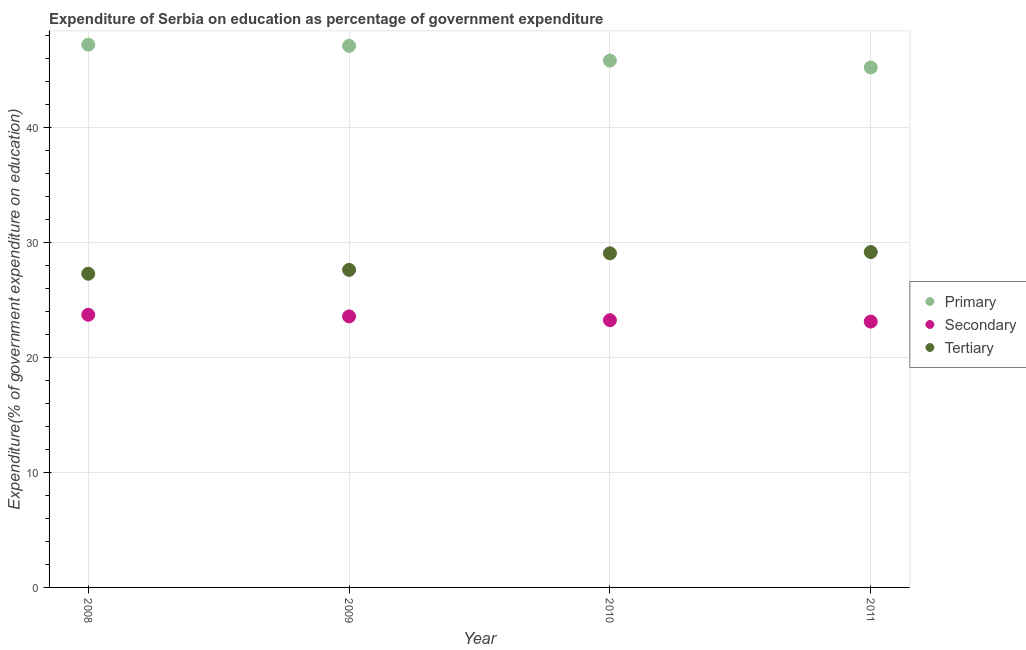Is the number of dotlines equal to the number of legend labels?
Provide a succinct answer. Yes. What is the expenditure on secondary education in 2009?
Your answer should be very brief. 23.59. Across all years, what is the maximum expenditure on tertiary education?
Make the answer very short. 29.19. Across all years, what is the minimum expenditure on primary education?
Your response must be concise. 45.26. In which year was the expenditure on tertiary education minimum?
Offer a terse response. 2008. What is the total expenditure on tertiary education in the graph?
Your response must be concise. 113.21. What is the difference between the expenditure on secondary education in 2008 and that in 2010?
Provide a succinct answer. 0.47. What is the difference between the expenditure on primary education in 2011 and the expenditure on tertiary education in 2009?
Ensure brevity in your answer.  17.62. What is the average expenditure on tertiary education per year?
Keep it short and to the point. 28.3. In the year 2009, what is the difference between the expenditure on tertiary education and expenditure on secondary education?
Your answer should be compact. 4.05. In how many years, is the expenditure on secondary education greater than 46 %?
Ensure brevity in your answer.  0. What is the ratio of the expenditure on tertiary education in 2009 to that in 2010?
Your response must be concise. 0.95. Is the expenditure on secondary education in 2008 less than that in 2010?
Make the answer very short. No. Is the difference between the expenditure on primary education in 2009 and 2010 greater than the difference between the expenditure on secondary education in 2009 and 2010?
Provide a succinct answer. Yes. What is the difference between the highest and the second highest expenditure on secondary education?
Provide a succinct answer. 0.14. What is the difference between the highest and the lowest expenditure on tertiary education?
Make the answer very short. 1.89. Does the expenditure on primary education monotonically increase over the years?
Provide a short and direct response. No. Is the expenditure on tertiary education strictly greater than the expenditure on secondary education over the years?
Your answer should be very brief. Yes. How many dotlines are there?
Offer a very short reply. 3. How many years are there in the graph?
Your response must be concise. 4. What is the difference between two consecutive major ticks on the Y-axis?
Your response must be concise. 10. Are the values on the major ticks of Y-axis written in scientific E-notation?
Ensure brevity in your answer.  No. Does the graph contain grids?
Offer a very short reply. Yes. Where does the legend appear in the graph?
Offer a very short reply. Center right. How are the legend labels stacked?
Provide a short and direct response. Vertical. What is the title of the graph?
Provide a short and direct response. Expenditure of Serbia on education as percentage of government expenditure. Does "Infant(female)" appear as one of the legend labels in the graph?
Your answer should be compact. No. What is the label or title of the X-axis?
Your response must be concise. Year. What is the label or title of the Y-axis?
Offer a very short reply. Expenditure(% of government expenditure on education). What is the Expenditure(% of government expenditure on education) in Primary in 2008?
Offer a terse response. 47.24. What is the Expenditure(% of government expenditure on education) of Secondary in 2008?
Offer a terse response. 23.73. What is the Expenditure(% of government expenditure on education) in Tertiary in 2008?
Give a very brief answer. 27.3. What is the Expenditure(% of government expenditure on education) of Primary in 2009?
Ensure brevity in your answer.  47.14. What is the Expenditure(% of government expenditure on education) of Secondary in 2009?
Provide a succinct answer. 23.59. What is the Expenditure(% of government expenditure on education) of Tertiary in 2009?
Provide a succinct answer. 27.64. What is the Expenditure(% of government expenditure on education) in Primary in 2010?
Ensure brevity in your answer.  45.86. What is the Expenditure(% of government expenditure on education) of Secondary in 2010?
Give a very brief answer. 23.26. What is the Expenditure(% of government expenditure on education) of Tertiary in 2010?
Ensure brevity in your answer.  29.08. What is the Expenditure(% of government expenditure on education) of Primary in 2011?
Your answer should be compact. 45.26. What is the Expenditure(% of government expenditure on education) in Secondary in 2011?
Provide a succinct answer. 23.14. What is the Expenditure(% of government expenditure on education) in Tertiary in 2011?
Your answer should be compact. 29.19. Across all years, what is the maximum Expenditure(% of government expenditure on education) in Primary?
Your answer should be compact. 47.24. Across all years, what is the maximum Expenditure(% of government expenditure on education) in Secondary?
Ensure brevity in your answer.  23.73. Across all years, what is the maximum Expenditure(% of government expenditure on education) in Tertiary?
Keep it short and to the point. 29.19. Across all years, what is the minimum Expenditure(% of government expenditure on education) of Primary?
Give a very brief answer. 45.26. Across all years, what is the minimum Expenditure(% of government expenditure on education) of Secondary?
Your answer should be compact. 23.14. Across all years, what is the minimum Expenditure(% of government expenditure on education) of Tertiary?
Keep it short and to the point. 27.3. What is the total Expenditure(% of government expenditure on education) in Primary in the graph?
Provide a succinct answer. 185.49. What is the total Expenditure(% of government expenditure on education) in Secondary in the graph?
Your answer should be very brief. 93.72. What is the total Expenditure(% of government expenditure on education) of Tertiary in the graph?
Provide a succinct answer. 113.21. What is the difference between the Expenditure(% of government expenditure on education) in Primary in 2008 and that in 2009?
Your response must be concise. 0.1. What is the difference between the Expenditure(% of government expenditure on education) of Secondary in 2008 and that in 2009?
Offer a terse response. 0.14. What is the difference between the Expenditure(% of government expenditure on education) of Tertiary in 2008 and that in 2009?
Keep it short and to the point. -0.34. What is the difference between the Expenditure(% of government expenditure on education) of Primary in 2008 and that in 2010?
Your response must be concise. 1.38. What is the difference between the Expenditure(% of government expenditure on education) of Secondary in 2008 and that in 2010?
Offer a terse response. 0.47. What is the difference between the Expenditure(% of government expenditure on education) of Tertiary in 2008 and that in 2010?
Your response must be concise. -1.78. What is the difference between the Expenditure(% of government expenditure on education) in Primary in 2008 and that in 2011?
Keep it short and to the point. 1.98. What is the difference between the Expenditure(% of government expenditure on education) of Secondary in 2008 and that in 2011?
Ensure brevity in your answer.  0.59. What is the difference between the Expenditure(% of government expenditure on education) of Tertiary in 2008 and that in 2011?
Your answer should be compact. -1.89. What is the difference between the Expenditure(% of government expenditure on education) of Primary in 2009 and that in 2010?
Provide a succinct answer. 1.28. What is the difference between the Expenditure(% of government expenditure on education) of Secondary in 2009 and that in 2010?
Your answer should be compact. 0.33. What is the difference between the Expenditure(% of government expenditure on education) in Tertiary in 2009 and that in 2010?
Ensure brevity in your answer.  -1.44. What is the difference between the Expenditure(% of government expenditure on education) in Primary in 2009 and that in 2011?
Offer a very short reply. 1.88. What is the difference between the Expenditure(% of government expenditure on education) in Secondary in 2009 and that in 2011?
Provide a short and direct response. 0.45. What is the difference between the Expenditure(% of government expenditure on education) in Tertiary in 2009 and that in 2011?
Make the answer very short. -1.55. What is the difference between the Expenditure(% of government expenditure on education) in Primary in 2010 and that in 2011?
Offer a terse response. 0.6. What is the difference between the Expenditure(% of government expenditure on education) of Secondary in 2010 and that in 2011?
Offer a very short reply. 0.12. What is the difference between the Expenditure(% of government expenditure on education) in Tertiary in 2010 and that in 2011?
Offer a very short reply. -0.11. What is the difference between the Expenditure(% of government expenditure on education) of Primary in 2008 and the Expenditure(% of government expenditure on education) of Secondary in 2009?
Give a very brief answer. 23.65. What is the difference between the Expenditure(% of government expenditure on education) in Primary in 2008 and the Expenditure(% of government expenditure on education) in Tertiary in 2009?
Keep it short and to the point. 19.6. What is the difference between the Expenditure(% of government expenditure on education) in Secondary in 2008 and the Expenditure(% of government expenditure on education) in Tertiary in 2009?
Ensure brevity in your answer.  -3.91. What is the difference between the Expenditure(% of government expenditure on education) of Primary in 2008 and the Expenditure(% of government expenditure on education) of Secondary in 2010?
Offer a terse response. 23.98. What is the difference between the Expenditure(% of government expenditure on education) of Primary in 2008 and the Expenditure(% of government expenditure on education) of Tertiary in 2010?
Your answer should be very brief. 18.16. What is the difference between the Expenditure(% of government expenditure on education) in Secondary in 2008 and the Expenditure(% of government expenditure on education) in Tertiary in 2010?
Ensure brevity in your answer.  -5.35. What is the difference between the Expenditure(% of government expenditure on education) in Primary in 2008 and the Expenditure(% of government expenditure on education) in Secondary in 2011?
Make the answer very short. 24.1. What is the difference between the Expenditure(% of government expenditure on education) in Primary in 2008 and the Expenditure(% of government expenditure on education) in Tertiary in 2011?
Your answer should be very brief. 18.05. What is the difference between the Expenditure(% of government expenditure on education) in Secondary in 2008 and the Expenditure(% of government expenditure on education) in Tertiary in 2011?
Provide a short and direct response. -5.46. What is the difference between the Expenditure(% of government expenditure on education) in Primary in 2009 and the Expenditure(% of government expenditure on education) in Secondary in 2010?
Keep it short and to the point. 23.88. What is the difference between the Expenditure(% of government expenditure on education) in Primary in 2009 and the Expenditure(% of government expenditure on education) in Tertiary in 2010?
Your response must be concise. 18.05. What is the difference between the Expenditure(% of government expenditure on education) of Secondary in 2009 and the Expenditure(% of government expenditure on education) of Tertiary in 2010?
Make the answer very short. -5.49. What is the difference between the Expenditure(% of government expenditure on education) in Primary in 2009 and the Expenditure(% of government expenditure on education) in Secondary in 2011?
Provide a succinct answer. 24. What is the difference between the Expenditure(% of government expenditure on education) in Primary in 2009 and the Expenditure(% of government expenditure on education) in Tertiary in 2011?
Give a very brief answer. 17.95. What is the difference between the Expenditure(% of government expenditure on education) of Secondary in 2009 and the Expenditure(% of government expenditure on education) of Tertiary in 2011?
Keep it short and to the point. -5.6. What is the difference between the Expenditure(% of government expenditure on education) in Primary in 2010 and the Expenditure(% of government expenditure on education) in Secondary in 2011?
Ensure brevity in your answer.  22.72. What is the difference between the Expenditure(% of government expenditure on education) in Primary in 2010 and the Expenditure(% of government expenditure on education) in Tertiary in 2011?
Ensure brevity in your answer.  16.66. What is the difference between the Expenditure(% of government expenditure on education) in Secondary in 2010 and the Expenditure(% of government expenditure on education) in Tertiary in 2011?
Offer a very short reply. -5.93. What is the average Expenditure(% of government expenditure on education) of Primary per year?
Offer a very short reply. 46.37. What is the average Expenditure(% of government expenditure on education) of Secondary per year?
Your response must be concise. 23.43. What is the average Expenditure(% of government expenditure on education) in Tertiary per year?
Provide a short and direct response. 28.3. In the year 2008, what is the difference between the Expenditure(% of government expenditure on education) in Primary and Expenditure(% of government expenditure on education) in Secondary?
Your answer should be compact. 23.51. In the year 2008, what is the difference between the Expenditure(% of government expenditure on education) in Primary and Expenditure(% of government expenditure on education) in Tertiary?
Provide a short and direct response. 19.94. In the year 2008, what is the difference between the Expenditure(% of government expenditure on education) in Secondary and Expenditure(% of government expenditure on education) in Tertiary?
Your response must be concise. -3.57. In the year 2009, what is the difference between the Expenditure(% of government expenditure on education) of Primary and Expenditure(% of government expenditure on education) of Secondary?
Keep it short and to the point. 23.55. In the year 2009, what is the difference between the Expenditure(% of government expenditure on education) of Primary and Expenditure(% of government expenditure on education) of Tertiary?
Make the answer very short. 19.5. In the year 2009, what is the difference between the Expenditure(% of government expenditure on education) of Secondary and Expenditure(% of government expenditure on education) of Tertiary?
Offer a terse response. -4.05. In the year 2010, what is the difference between the Expenditure(% of government expenditure on education) of Primary and Expenditure(% of government expenditure on education) of Secondary?
Ensure brevity in your answer.  22.6. In the year 2010, what is the difference between the Expenditure(% of government expenditure on education) in Primary and Expenditure(% of government expenditure on education) in Tertiary?
Ensure brevity in your answer.  16.77. In the year 2010, what is the difference between the Expenditure(% of government expenditure on education) of Secondary and Expenditure(% of government expenditure on education) of Tertiary?
Keep it short and to the point. -5.82. In the year 2011, what is the difference between the Expenditure(% of government expenditure on education) in Primary and Expenditure(% of government expenditure on education) in Secondary?
Your answer should be very brief. 22.12. In the year 2011, what is the difference between the Expenditure(% of government expenditure on education) of Primary and Expenditure(% of government expenditure on education) of Tertiary?
Your answer should be very brief. 16.07. In the year 2011, what is the difference between the Expenditure(% of government expenditure on education) in Secondary and Expenditure(% of government expenditure on education) in Tertiary?
Provide a succinct answer. -6.05. What is the ratio of the Expenditure(% of government expenditure on education) in Primary in 2008 to that in 2009?
Make the answer very short. 1. What is the ratio of the Expenditure(% of government expenditure on education) of Primary in 2008 to that in 2010?
Give a very brief answer. 1.03. What is the ratio of the Expenditure(% of government expenditure on education) of Secondary in 2008 to that in 2010?
Provide a short and direct response. 1.02. What is the ratio of the Expenditure(% of government expenditure on education) of Tertiary in 2008 to that in 2010?
Your answer should be compact. 0.94. What is the ratio of the Expenditure(% of government expenditure on education) of Primary in 2008 to that in 2011?
Ensure brevity in your answer.  1.04. What is the ratio of the Expenditure(% of government expenditure on education) in Secondary in 2008 to that in 2011?
Ensure brevity in your answer.  1.03. What is the ratio of the Expenditure(% of government expenditure on education) in Tertiary in 2008 to that in 2011?
Give a very brief answer. 0.94. What is the ratio of the Expenditure(% of government expenditure on education) in Primary in 2009 to that in 2010?
Your response must be concise. 1.03. What is the ratio of the Expenditure(% of government expenditure on education) of Secondary in 2009 to that in 2010?
Keep it short and to the point. 1.01. What is the ratio of the Expenditure(% of government expenditure on education) of Tertiary in 2009 to that in 2010?
Your answer should be very brief. 0.95. What is the ratio of the Expenditure(% of government expenditure on education) of Primary in 2009 to that in 2011?
Make the answer very short. 1.04. What is the ratio of the Expenditure(% of government expenditure on education) of Secondary in 2009 to that in 2011?
Provide a short and direct response. 1.02. What is the ratio of the Expenditure(% of government expenditure on education) in Tertiary in 2009 to that in 2011?
Offer a terse response. 0.95. What is the ratio of the Expenditure(% of government expenditure on education) of Primary in 2010 to that in 2011?
Give a very brief answer. 1.01. What is the ratio of the Expenditure(% of government expenditure on education) in Secondary in 2010 to that in 2011?
Offer a terse response. 1.01. What is the difference between the highest and the second highest Expenditure(% of government expenditure on education) in Primary?
Make the answer very short. 0.1. What is the difference between the highest and the second highest Expenditure(% of government expenditure on education) of Secondary?
Provide a short and direct response. 0.14. What is the difference between the highest and the second highest Expenditure(% of government expenditure on education) in Tertiary?
Your response must be concise. 0.11. What is the difference between the highest and the lowest Expenditure(% of government expenditure on education) of Primary?
Give a very brief answer. 1.98. What is the difference between the highest and the lowest Expenditure(% of government expenditure on education) in Secondary?
Provide a short and direct response. 0.59. What is the difference between the highest and the lowest Expenditure(% of government expenditure on education) in Tertiary?
Keep it short and to the point. 1.89. 